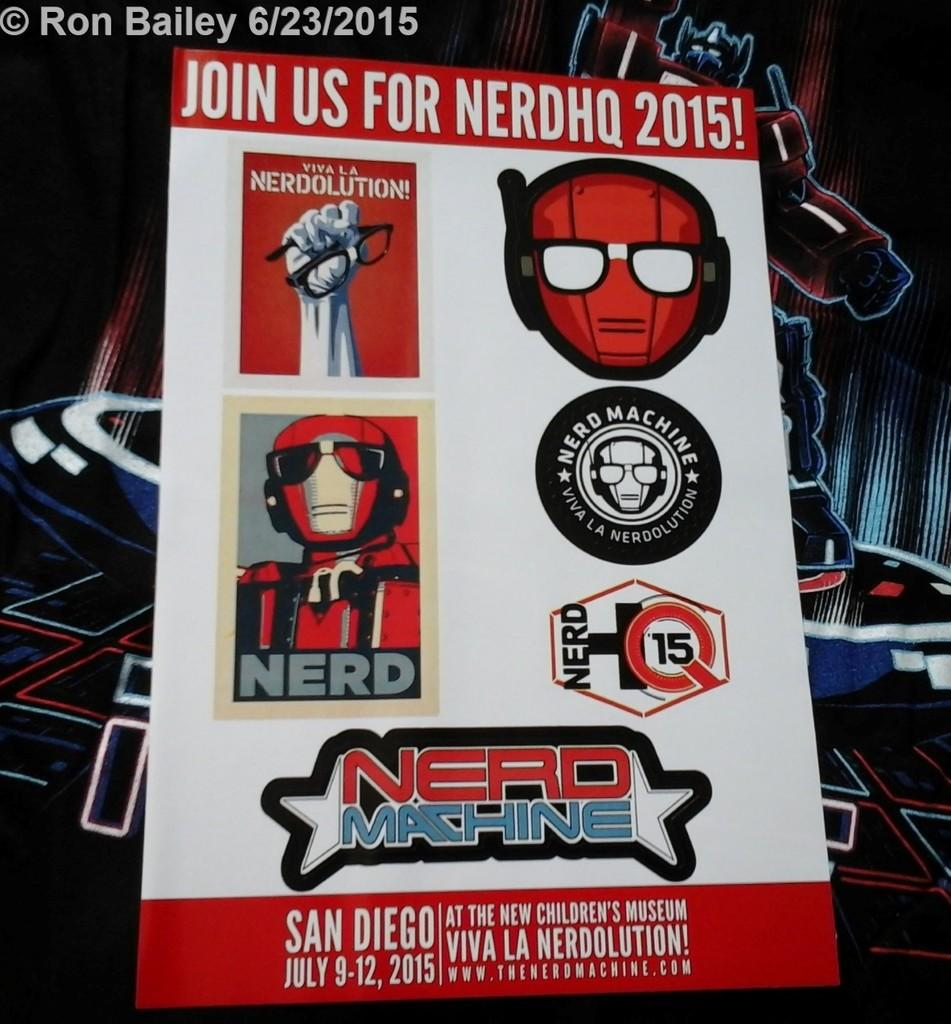<image>
Describe the image concisely. A poster advertising an event which states JOIN US FOR NERDHQ 2015! 